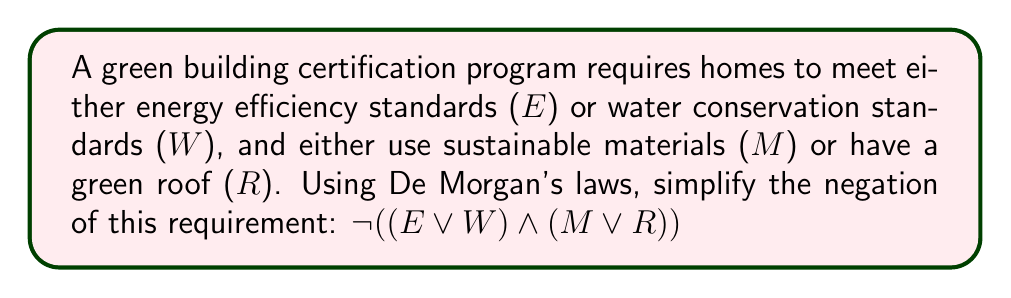Solve this math problem. To simplify the negation of the given expression using De Morgan's laws, we'll follow these steps:

1) Start with the original expression: $\neg ((E \lor W) \land (M \lor R))$

2) Apply De Morgan's first law to the outer negation:
   $\neg ((E \lor W) \land (M \lor R)) = \neg (E \lor W) \lor \neg (M \lor R)$

3) Apply De Morgan's second law to each of the inner negations:
   $\neg (E \lor W) \lor \neg (M \lor R) = (\neg E \land \neg W) \lor (\neg M \land \neg R)$

4) This simplified expression represents the conditions under which a home would not meet the certification requirements. It states that a home fails to meet the requirements if:
   - It neither meets energy efficiency standards nor water conservation standards, OR
   - It neither uses sustainable materials nor has a green roof.

This logical analysis helps environmental officers understand and communicate the specific conditions under which a home would fail to meet green building certification requirements.
Answer: $(\neg E \land \neg W) \lor (\neg M \land \neg R)$ 